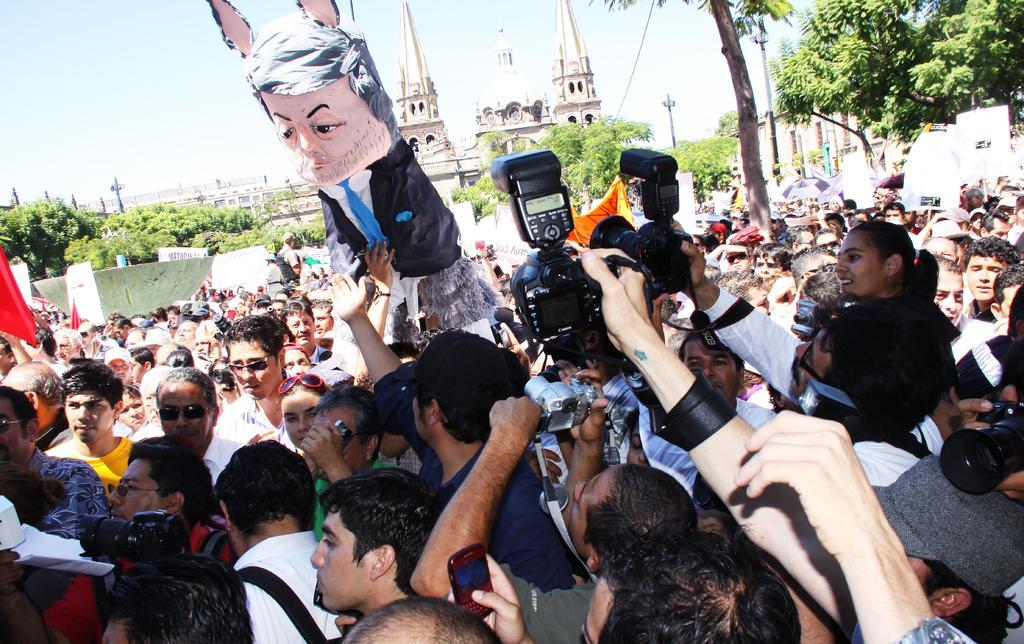How would you summarize this image in a sentence or two? This picture is clicked inside the city. Here, we see many people standing on the road. The man at the bottom of the picture is holding a camera in his hand and he is clicking photos on the camera. On the right side, we see people standing and holding white boards in their hands. There are trees and buildings in the background. We even see street lights and poles. At the top of the picture, we see the sky. 